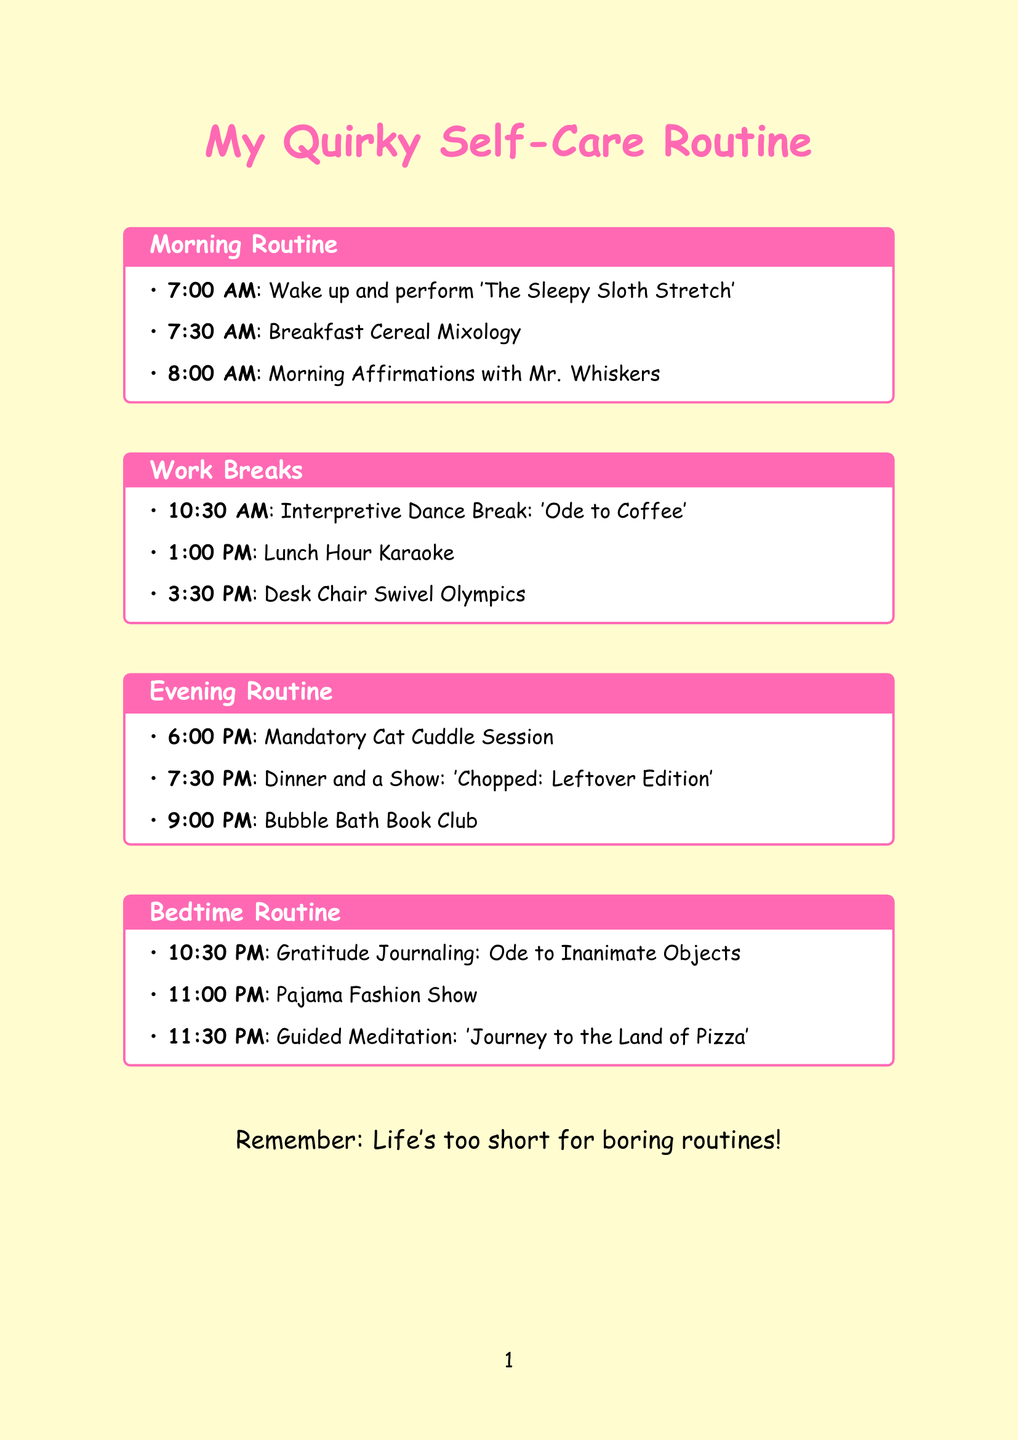What time is the 'Interpretive Dance Break: Ode to Coffee'? The document lists this activity at 10:30 AM.
Answer: 10:30 AM What activity involves Mr. Whiskers? This is part of the morning routine, specifically at 8:00 AM.
Answer: Morning Affirmations with Mr. Whiskers How long is the Mandatory Cat Cuddle Session? The document states that this session lasts for 15 minutes.
Answer: 15 minutes What do you do during the Bubble Bath Book Club? This activity involves reading a chapter from a trashy romance novel during a bubble bath.
Answer: Read a chapter from a trashy romance novel What unique theme does the Guided Meditation have? The meditation centers around a whimsical theme of pizza toppings.
Answer: Journey to the Land of Pizza 